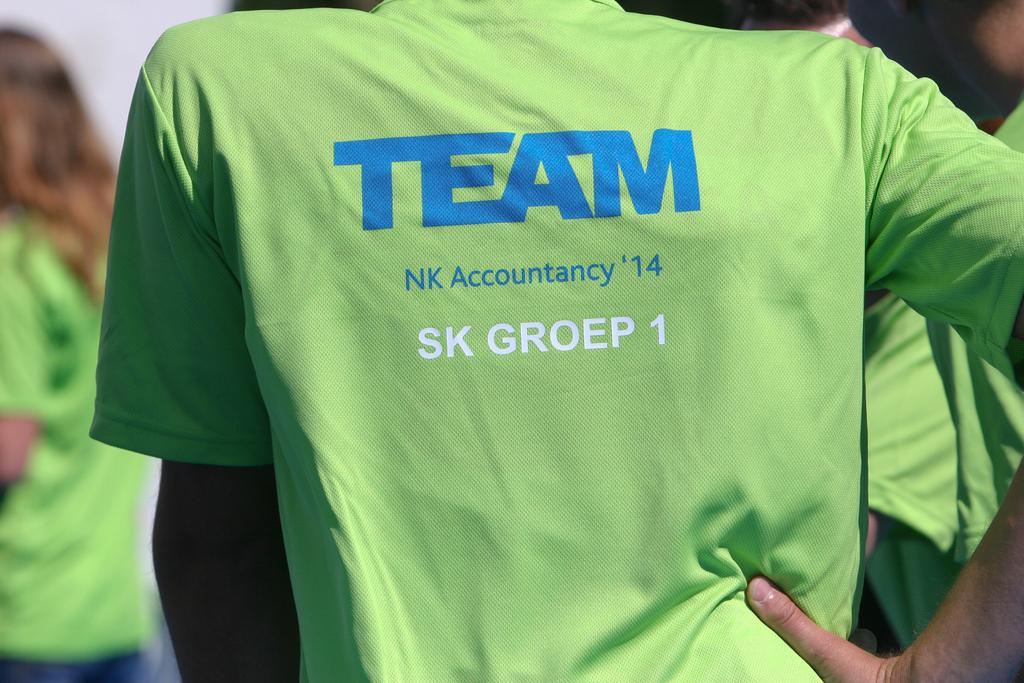<image>
Create a compact narrative representing the image presented. An athletic uniform has the word team on the back. 